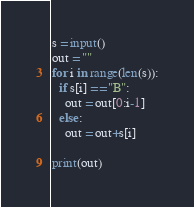Convert code to text. <code><loc_0><loc_0><loc_500><loc_500><_Python_>s = input()
out = ""
for i in range(len(s)):
  if s[i] == "B":
    out = out[0:i-1]
  else:
    out = out+s[i]
    
print(out)</code> 